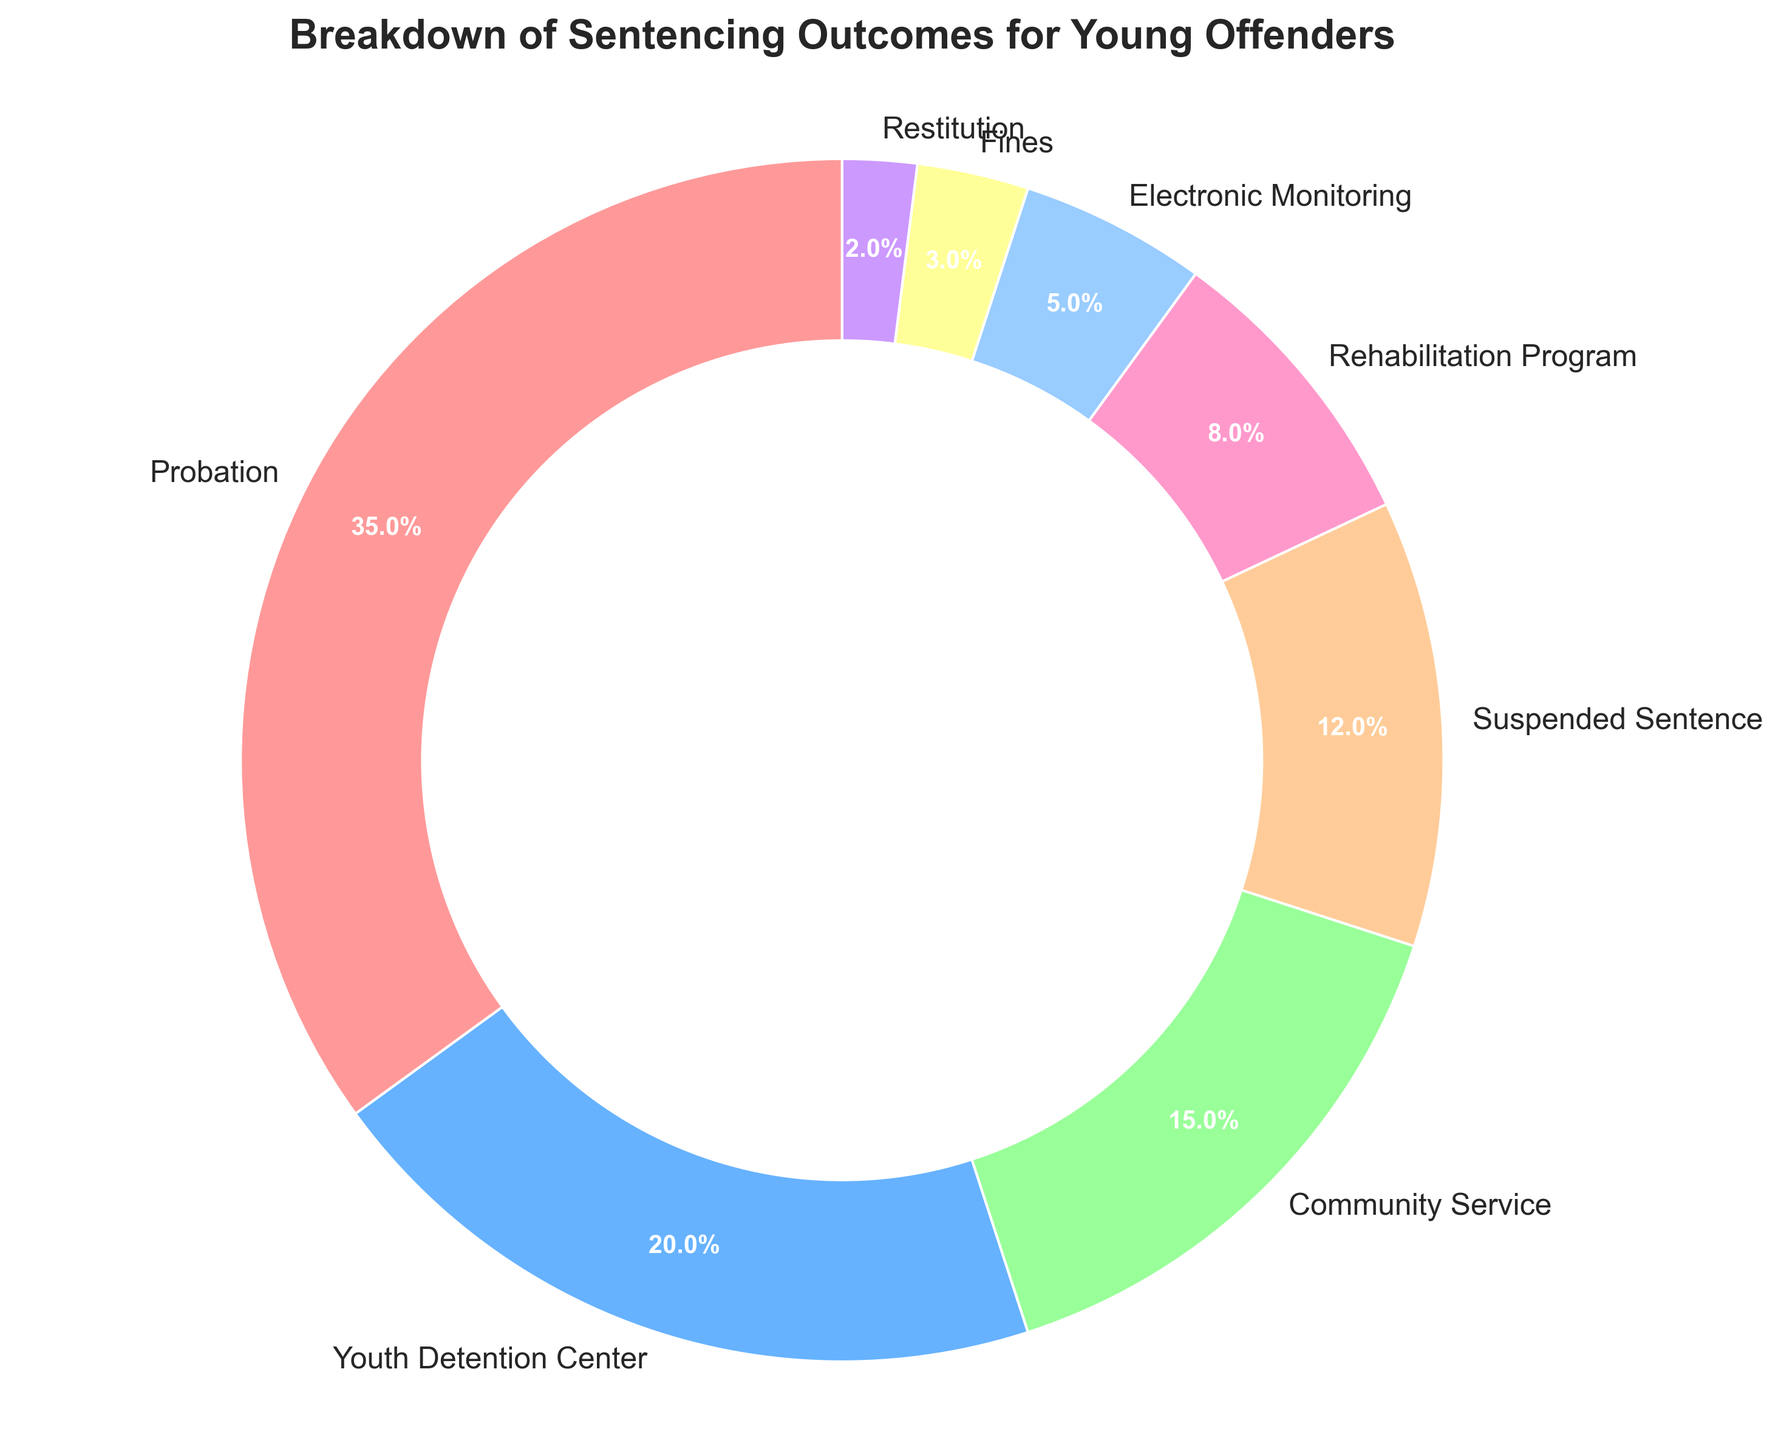What is the most common sentencing outcome for young offenders? The chart shows that the largest segment is labeled "Probation" with a percentage of 35%, which indicates it is the most common sentencing outcome.
Answer: Probation What percentage of young offenders are sentenced to either community service or rehabilitation programs? To find this, add the percentages for "Community Service" and "Rehabilitation Program". 15% + 8% = 23%.
Answer: 23% Which sentencing outcome is more common: electronic monitoring or fines? Comparing the chart segments, electronic monitoring occupies a larger portion at 5% compared to fines at 3%.
Answer: Electronic Monitoring How much larger is the percentage of probation compared to youth detention center? Subtract the percentage for youth detention center (20%) from the percentage for probation (35%): 35% - 20% = 15%.
Answer: 15% What is the combined percentage of outcomes that involve some form of incarceration or confinement? Add the percentages of "Youth Detention Center" (20%) and "Electronic Monitoring" (5%): 20% + 5% = 25%.
Answer: 25% Is the percentage of suspended sentences greater than that of community service? The chart shows that the percentage for suspended sentences is 12%, which is less than the percentage for community service at 15%.
Answer: No What proportion of the pie chart is made up of suspended sentences and restitution combined? Adding the percentages for "Suspended Sentence" (12%) and "Restitution" (2%) gives 14%.
Answer: 14% Among the listed sentencing outcomes, which one has the smallest percentage and what is it? The chart displays "Restitution" as the smallest segment with a percentage of 2%.
Answer: Restitution, 2% What is the difference in percentage between community service and electronic monitoring? Subtract the percentage of electronic monitoring (5%) from the percentage of community service (15%): 15% - 5% = 10%.
Answer: 10% If you were to combine all forms of non-incarceration outcomes (Probation, Fines, Community Service, Rehabilitation Program, Restitution), what percentage would you get? Sum of percentages for probation (35%), fines (3%), community service (15%), rehabilitation program (8%), and restitution (2%) equals 63%.
Answer: 63% 